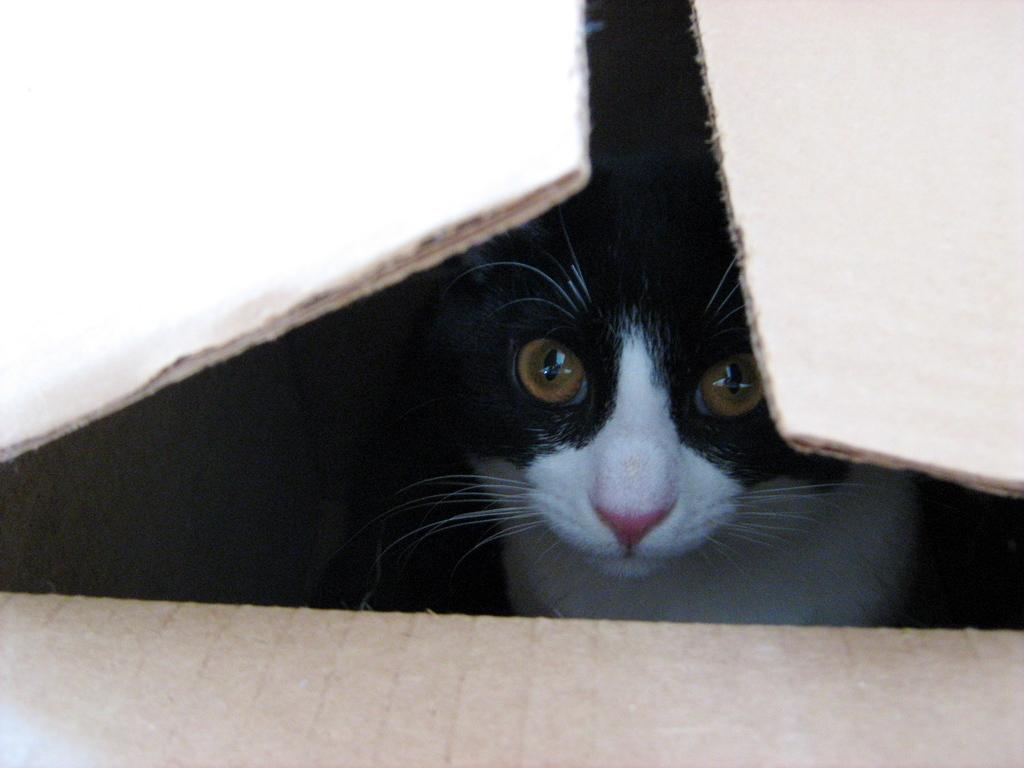What type of animal is in the image? There is a cat in the image. Where is the cat located in the image? The cat is in a box. How does the cat express regret in the image? There is no indication in the image that the cat is expressing regret, as cats do not have the ability to express emotions like regret. 